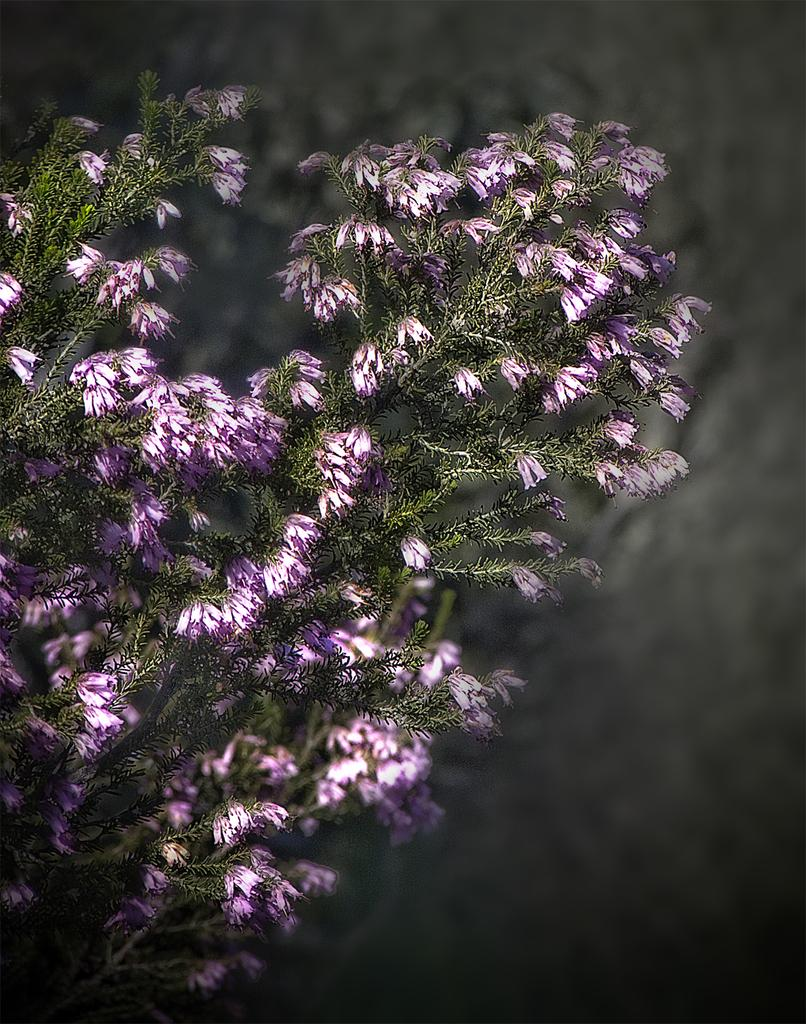What is the main subject of the image? The main subject of the image is a bunch of flowers. Can you describe the background of the image? The background of the image is blurred. What type of pan can be seen in the image? There is no pan present in the image. What kind of pain is the person in the image experiencing? There is no person or pain mentioned in the image; it features a bunch of flowers and a blurred background. 